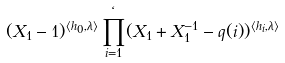<formula> <loc_0><loc_0><loc_500><loc_500>( X _ { 1 } - 1 ) ^ { \langle h _ { 0 } , \lambda \rangle } \prod _ { i = 1 } ^ { \ell } ( X _ { 1 } + X _ { 1 } ^ { - 1 } - q ( i ) ) ^ { \langle h _ { i } , \lambda \rangle }</formula> 